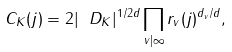<formula> <loc_0><loc_0><loc_500><loc_500>C _ { K } ( j ) = 2 | \ D _ { K } | ^ { 1 / 2 d } \prod _ { v | \infty } r _ { v } ( j ) ^ { d _ { v } / d } ,</formula> 